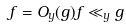Convert formula to latex. <formula><loc_0><loc_0><loc_500><loc_500>f = O _ { y } ( g ) f \ll _ { y } g</formula> 